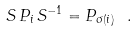<formula> <loc_0><loc_0><loc_500><loc_500>S \, P _ { i } \, S ^ { - 1 } = P _ { \sigma ( i ) } \ .</formula> 